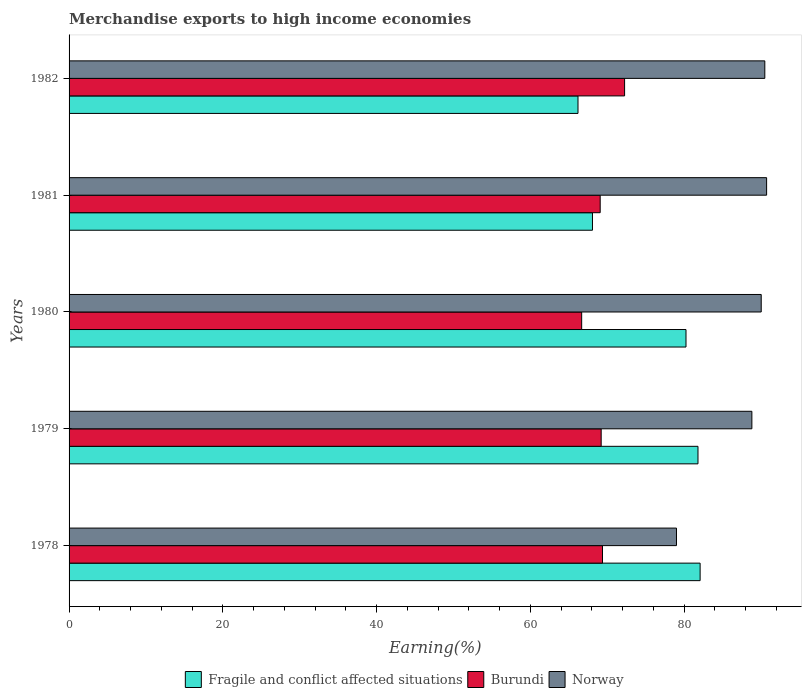How many groups of bars are there?
Your answer should be very brief. 5. Are the number of bars per tick equal to the number of legend labels?
Keep it short and to the point. Yes. How many bars are there on the 2nd tick from the top?
Make the answer very short. 3. How many bars are there on the 1st tick from the bottom?
Give a very brief answer. 3. What is the label of the 4th group of bars from the top?
Make the answer very short. 1979. What is the percentage of amount earned from merchandise exports in Norway in 1978?
Give a very brief answer. 79.01. Across all years, what is the maximum percentage of amount earned from merchandise exports in Fragile and conflict affected situations?
Provide a short and direct response. 82.08. Across all years, what is the minimum percentage of amount earned from merchandise exports in Fragile and conflict affected situations?
Give a very brief answer. 66.2. In which year was the percentage of amount earned from merchandise exports in Fragile and conflict affected situations maximum?
Make the answer very short. 1978. In which year was the percentage of amount earned from merchandise exports in Fragile and conflict affected situations minimum?
Provide a succinct answer. 1982. What is the total percentage of amount earned from merchandise exports in Fragile and conflict affected situations in the graph?
Ensure brevity in your answer.  378.4. What is the difference between the percentage of amount earned from merchandise exports in Fragile and conflict affected situations in 1978 and that in 1981?
Provide a succinct answer. 14. What is the difference between the percentage of amount earned from merchandise exports in Norway in 1981 and the percentage of amount earned from merchandise exports in Burundi in 1979?
Provide a short and direct response. 21.52. What is the average percentage of amount earned from merchandise exports in Norway per year?
Give a very brief answer. 87.81. In the year 1979, what is the difference between the percentage of amount earned from merchandise exports in Norway and percentage of amount earned from merchandise exports in Fragile and conflict affected situations?
Provide a short and direct response. 7.01. In how many years, is the percentage of amount earned from merchandise exports in Burundi greater than 48 %?
Provide a short and direct response. 5. What is the ratio of the percentage of amount earned from merchandise exports in Norway in 1978 to that in 1982?
Offer a terse response. 0.87. What is the difference between the highest and the second highest percentage of amount earned from merchandise exports in Norway?
Your answer should be compact. 0.23. What is the difference between the highest and the lowest percentage of amount earned from merchandise exports in Norway?
Offer a terse response. 11.72. In how many years, is the percentage of amount earned from merchandise exports in Fragile and conflict affected situations greater than the average percentage of amount earned from merchandise exports in Fragile and conflict affected situations taken over all years?
Your answer should be compact. 3. What does the 1st bar from the bottom in 1978 represents?
Keep it short and to the point. Fragile and conflict affected situations. Are all the bars in the graph horizontal?
Your answer should be compact. Yes. How many years are there in the graph?
Provide a short and direct response. 5. Where does the legend appear in the graph?
Offer a terse response. Bottom center. What is the title of the graph?
Provide a short and direct response. Merchandise exports to high income economies. What is the label or title of the X-axis?
Your response must be concise. Earning(%). What is the Earning(%) of Fragile and conflict affected situations in 1978?
Provide a short and direct response. 82.08. What is the Earning(%) in Burundi in 1978?
Your answer should be compact. 69.38. What is the Earning(%) in Norway in 1978?
Provide a short and direct response. 79.01. What is the Earning(%) in Fragile and conflict affected situations in 1979?
Your response must be concise. 81.8. What is the Earning(%) in Burundi in 1979?
Provide a short and direct response. 69.21. What is the Earning(%) in Norway in 1979?
Ensure brevity in your answer.  88.81. What is the Earning(%) of Fragile and conflict affected situations in 1980?
Provide a succinct answer. 80.24. What is the Earning(%) of Burundi in 1980?
Keep it short and to the point. 66.67. What is the Earning(%) in Norway in 1980?
Keep it short and to the point. 90.03. What is the Earning(%) in Fragile and conflict affected situations in 1981?
Give a very brief answer. 68.08. What is the Earning(%) of Burundi in 1981?
Keep it short and to the point. 69.08. What is the Earning(%) in Norway in 1981?
Offer a terse response. 90.73. What is the Earning(%) of Fragile and conflict affected situations in 1982?
Keep it short and to the point. 66.2. What is the Earning(%) of Burundi in 1982?
Keep it short and to the point. 72.26. What is the Earning(%) in Norway in 1982?
Provide a succinct answer. 90.5. Across all years, what is the maximum Earning(%) in Fragile and conflict affected situations?
Provide a succinct answer. 82.08. Across all years, what is the maximum Earning(%) of Burundi?
Give a very brief answer. 72.26. Across all years, what is the maximum Earning(%) of Norway?
Provide a succinct answer. 90.73. Across all years, what is the minimum Earning(%) of Fragile and conflict affected situations?
Your response must be concise. 66.2. Across all years, what is the minimum Earning(%) in Burundi?
Your response must be concise. 66.67. Across all years, what is the minimum Earning(%) in Norway?
Keep it short and to the point. 79.01. What is the total Earning(%) of Fragile and conflict affected situations in the graph?
Your response must be concise. 378.4. What is the total Earning(%) of Burundi in the graph?
Your answer should be compact. 346.61. What is the total Earning(%) in Norway in the graph?
Offer a terse response. 439.07. What is the difference between the Earning(%) of Fragile and conflict affected situations in 1978 and that in 1979?
Make the answer very short. 0.28. What is the difference between the Earning(%) in Burundi in 1978 and that in 1979?
Make the answer very short. 0.17. What is the difference between the Earning(%) in Norway in 1978 and that in 1979?
Your answer should be very brief. -9.81. What is the difference between the Earning(%) in Fragile and conflict affected situations in 1978 and that in 1980?
Ensure brevity in your answer.  1.84. What is the difference between the Earning(%) in Burundi in 1978 and that in 1980?
Make the answer very short. 2.71. What is the difference between the Earning(%) of Norway in 1978 and that in 1980?
Keep it short and to the point. -11.02. What is the difference between the Earning(%) of Fragile and conflict affected situations in 1978 and that in 1981?
Make the answer very short. 14. What is the difference between the Earning(%) in Burundi in 1978 and that in 1981?
Provide a succinct answer. 0.3. What is the difference between the Earning(%) of Norway in 1978 and that in 1981?
Ensure brevity in your answer.  -11.72. What is the difference between the Earning(%) of Fragile and conflict affected situations in 1978 and that in 1982?
Offer a very short reply. 15.88. What is the difference between the Earning(%) in Burundi in 1978 and that in 1982?
Offer a very short reply. -2.88. What is the difference between the Earning(%) in Norway in 1978 and that in 1982?
Ensure brevity in your answer.  -11.49. What is the difference between the Earning(%) of Fragile and conflict affected situations in 1979 and that in 1980?
Offer a terse response. 1.56. What is the difference between the Earning(%) of Burundi in 1979 and that in 1980?
Offer a terse response. 2.54. What is the difference between the Earning(%) of Norway in 1979 and that in 1980?
Give a very brief answer. -1.22. What is the difference between the Earning(%) of Fragile and conflict affected situations in 1979 and that in 1981?
Ensure brevity in your answer.  13.72. What is the difference between the Earning(%) in Burundi in 1979 and that in 1981?
Your response must be concise. 0.13. What is the difference between the Earning(%) of Norway in 1979 and that in 1981?
Offer a very short reply. -1.92. What is the difference between the Earning(%) in Fragile and conflict affected situations in 1979 and that in 1982?
Your answer should be very brief. 15.61. What is the difference between the Earning(%) of Burundi in 1979 and that in 1982?
Provide a short and direct response. -3.05. What is the difference between the Earning(%) in Norway in 1979 and that in 1982?
Offer a terse response. -1.68. What is the difference between the Earning(%) of Fragile and conflict affected situations in 1980 and that in 1981?
Your response must be concise. 12.17. What is the difference between the Earning(%) of Burundi in 1980 and that in 1981?
Your answer should be very brief. -2.41. What is the difference between the Earning(%) in Norway in 1980 and that in 1981?
Your response must be concise. -0.7. What is the difference between the Earning(%) of Fragile and conflict affected situations in 1980 and that in 1982?
Offer a terse response. 14.05. What is the difference between the Earning(%) in Burundi in 1980 and that in 1982?
Offer a terse response. -5.58. What is the difference between the Earning(%) in Norway in 1980 and that in 1982?
Your response must be concise. -0.47. What is the difference between the Earning(%) of Fragile and conflict affected situations in 1981 and that in 1982?
Keep it short and to the point. 1.88. What is the difference between the Earning(%) in Burundi in 1981 and that in 1982?
Keep it short and to the point. -3.17. What is the difference between the Earning(%) in Norway in 1981 and that in 1982?
Your answer should be very brief. 0.23. What is the difference between the Earning(%) in Fragile and conflict affected situations in 1978 and the Earning(%) in Burundi in 1979?
Offer a very short reply. 12.87. What is the difference between the Earning(%) in Fragile and conflict affected situations in 1978 and the Earning(%) in Norway in 1979?
Provide a succinct answer. -6.73. What is the difference between the Earning(%) in Burundi in 1978 and the Earning(%) in Norway in 1979?
Make the answer very short. -19.43. What is the difference between the Earning(%) of Fragile and conflict affected situations in 1978 and the Earning(%) of Burundi in 1980?
Your response must be concise. 15.41. What is the difference between the Earning(%) in Fragile and conflict affected situations in 1978 and the Earning(%) in Norway in 1980?
Provide a succinct answer. -7.95. What is the difference between the Earning(%) in Burundi in 1978 and the Earning(%) in Norway in 1980?
Offer a terse response. -20.64. What is the difference between the Earning(%) in Fragile and conflict affected situations in 1978 and the Earning(%) in Burundi in 1981?
Your response must be concise. 13. What is the difference between the Earning(%) of Fragile and conflict affected situations in 1978 and the Earning(%) of Norway in 1981?
Provide a succinct answer. -8.65. What is the difference between the Earning(%) in Burundi in 1978 and the Earning(%) in Norway in 1981?
Provide a succinct answer. -21.35. What is the difference between the Earning(%) in Fragile and conflict affected situations in 1978 and the Earning(%) in Burundi in 1982?
Offer a very short reply. 9.82. What is the difference between the Earning(%) in Fragile and conflict affected situations in 1978 and the Earning(%) in Norway in 1982?
Ensure brevity in your answer.  -8.42. What is the difference between the Earning(%) of Burundi in 1978 and the Earning(%) of Norway in 1982?
Make the answer very short. -21.11. What is the difference between the Earning(%) of Fragile and conflict affected situations in 1979 and the Earning(%) of Burundi in 1980?
Make the answer very short. 15.13. What is the difference between the Earning(%) in Fragile and conflict affected situations in 1979 and the Earning(%) in Norway in 1980?
Your response must be concise. -8.22. What is the difference between the Earning(%) in Burundi in 1979 and the Earning(%) in Norway in 1980?
Ensure brevity in your answer.  -20.82. What is the difference between the Earning(%) in Fragile and conflict affected situations in 1979 and the Earning(%) in Burundi in 1981?
Make the answer very short. 12.72. What is the difference between the Earning(%) of Fragile and conflict affected situations in 1979 and the Earning(%) of Norway in 1981?
Make the answer very short. -8.93. What is the difference between the Earning(%) in Burundi in 1979 and the Earning(%) in Norway in 1981?
Offer a terse response. -21.52. What is the difference between the Earning(%) in Fragile and conflict affected situations in 1979 and the Earning(%) in Burundi in 1982?
Provide a succinct answer. 9.54. What is the difference between the Earning(%) of Fragile and conflict affected situations in 1979 and the Earning(%) of Norway in 1982?
Keep it short and to the point. -8.69. What is the difference between the Earning(%) of Burundi in 1979 and the Earning(%) of Norway in 1982?
Ensure brevity in your answer.  -21.28. What is the difference between the Earning(%) in Fragile and conflict affected situations in 1980 and the Earning(%) in Burundi in 1981?
Provide a short and direct response. 11.16. What is the difference between the Earning(%) in Fragile and conflict affected situations in 1980 and the Earning(%) in Norway in 1981?
Make the answer very short. -10.48. What is the difference between the Earning(%) in Burundi in 1980 and the Earning(%) in Norway in 1981?
Make the answer very short. -24.06. What is the difference between the Earning(%) in Fragile and conflict affected situations in 1980 and the Earning(%) in Burundi in 1982?
Offer a very short reply. 7.99. What is the difference between the Earning(%) in Fragile and conflict affected situations in 1980 and the Earning(%) in Norway in 1982?
Ensure brevity in your answer.  -10.25. What is the difference between the Earning(%) of Burundi in 1980 and the Earning(%) of Norway in 1982?
Provide a short and direct response. -23.82. What is the difference between the Earning(%) of Fragile and conflict affected situations in 1981 and the Earning(%) of Burundi in 1982?
Keep it short and to the point. -4.18. What is the difference between the Earning(%) in Fragile and conflict affected situations in 1981 and the Earning(%) in Norway in 1982?
Your response must be concise. -22.42. What is the difference between the Earning(%) in Burundi in 1981 and the Earning(%) in Norway in 1982?
Your answer should be very brief. -21.41. What is the average Earning(%) in Fragile and conflict affected situations per year?
Ensure brevity in your answer.  75.68. What is the average Earning(%) of Burundi per year?
Provide a short and direct response. 69.32. What is the average Earning(%) in Norway per year?
Give a very brief answer. 87.81. In the year 1978, what is the difference between the Earning(%) in Fragile and conflict affected situations and Earning(%) in Burundi?
Provide a short and direct response. 12.7. In the year 1978, what is the difference between the Earning(%) in Fragile and conflict affected situations and Earning(%) in Norway?
Your answer should be very brief. 3.07. In the year 1978, what is the difference between the Earning(%) of Burundi and Earning(%) of Norway?
Keep it short and to the point. -9.62. In the year 1979, what is the difference between the Earning(%) of Fragile and conflict affected situations and Earning(%) of Burundi?
Keep it short and to the point. 12.59. In the year 1979, what is the difference between the Earning(%) of Fragile and conflict affected situations and Earning(%) of Norway?
Make the answer very short. -7.01. In the year 1979, what is the difference between the Earning(%) in Burundi and Earning(%) in Norway?
Offer a very short reply. -19.6. In the year 1980, what is the difference between the Earning(%) in Fragile and conflict affected situations and Earning(%) in Burundi?
Offer a very short reply. 13.57. In the year 1980, what is the difference between the Earning(%) in Fragile and conflict affected situations and Earning(%) in Norway?
Keep it short and to the point. -9.78. In the year 1980, what is the difference between the Earning(%) in Burundi and Earning(%) in Norway?
Your answer should be compact. -23.35. In the year 1981, what is the difference between the Earning(%) in Fragile and conflict affected situations and Earning(%) in Burundi?
Give a very brief answer. -1.01. In the year 1981, what is the difference between the Earning(%) of Fragile and conflict affected situations and Earning(%) of Norway?
Your response must be concise. -22.65. In the year 1981, what is the difference between the Earning(%) of Burundi and Earning(%) of Norway?
Offer a very short reply. -21.65. In the year 1982, what is the difference between the Earning(%) of Fragile and conflict affected situations and Earning(%) of Burundi?
Keep it short and to the point. -6.06. In the year 1982, what is the difference between the Earning(%) of Fragile and conflict affected situations and Earning(%) of Norway?
Your answer should be very brief. -24.3. In the year 1982, what is the difference between the Earning(%) of Burundi and Earning(%) of Norway?
Your answer should be compact. -18.24. What is the ratio of the Earning(%) of Fragile and conflict affected situations in 1978 to that in 1979?
Your response must be concise. 1. What is the ratio of the Earning(%) in Norway in 1978 to that in 1979?
Offer a very short reply. 0.89. What is the ratio of the Earning(%) of Fragile and conflict affected situations in 1978 to that in 1980?
Provide a short and direct response. 1.02. What is the ratio of the Earning(%) in Burundi in 1978 to that in 1980?
Provide a short and direct response. 1.04. What is the ratio of the Earning(%) in Norway in 1978 to that in 1980?
Ensure brevity in your answer.  0.88. What is the ratio of the Earning(%) in Fragile and conflict affected situations in 1978 to that in 1981?
Your response must be concise. 1.21. What is the ratio of the Earning(%) of Norway in 1978 to that in 1981?
Give a very brief answer. 0.87. What is the ratio of the Earning(%) in Fragile and conflict affected situations in 1978 to that in 1982?
Keep it short and to the point. 1.24. What is the ratio of the Earning(%) in Burundi in 1978 to that in 1982?
Keep it short and to the point. 0.96. What is the ratio of the Earning(%) in Norway in 1978 to that in 1982?
Keep it short and to the point. 0.87. What is the ratio of the Earning(%) of Fragile and conflict affected situations in 1979 to that in 1980?
Ensure brevity in your answer.  1.02. What is the ratio of the Earning(%) of Burundi in 1979 to that in 1980?
Provide a succinct answer. 1.04. What is the ratio of the Earning(%) of Norway in 1979 to that in 1980?
Offer a very short reply. 0.99. What is the ratio of the Earning(%) of Fragile and conflict affected situations in 1979 to that in 1981?
Keep it short and to the point. 1.2. What is the ratio of the Earning(%) in Norway in 1979 to that in 1981?
Offer a terse response. 0.98. What is the ratio of the Earning(%) in Fragile and conflict affected situations in 1979 to that in 1982?
Make the answer very short. 1.24. What is the ratio of the Earning(%) of Burundi in 1979 to that in 1982?
Your response must be concise. 0.96. What is the ratio of the Earning(%) of Norway in 1979 to that in 1982?
Offer a terse response. 0.98. What is the ratio of the Earning(%) in Fragile and conflict affected situations in 1980 to that in 1981?
Your answer should be very brief. 1.18. What is the ratio of the Earning(%) in Burundi in 1980 to that in 1981?
Your response must be concise. 0.97. What is the ratio of the Earning(%) of Fragile and conflict affected situations in 1980 to that in 1982?
Make the answer very short. 1.21. What is the ratio of the Earning(%) of Burundi in 1980 to that in 1982?
Give a very brief answer. 0.92. What is the ratio of the Earning(%) in Fragile and conflict affected situations in 1981 to that in 1982?
Your response must be concise. 1.03. What is the ratio of the Earning(%) in Burundi in 1981 to that in 1982?
Your answer should be very brief. 0.96. What is the difference between the highest and the second highest Earning(%) in Fragile and conflict affected situations?
Provide a short and direct response. 0.28. What is the difference between the highest and the second highest Earning(%) in Burundi?
Provide a succinct answer. 2.88. What is the difference between the highest and the second highest Earning(%) of Norway?
Your answer should be very brief. 0.23. What is the difference between the highest and the lowest Earning(%) in Fragile and conflict affected situations?
Keep it short and to the point. 15.88. What is the difference between the highest and the lowest Earning(%) in Burundi?
Offer a terse response. 5.58. What is the difference between the highest and the lowest Earning(%) in Norway?
Provide a succinct answer. 11.72. 